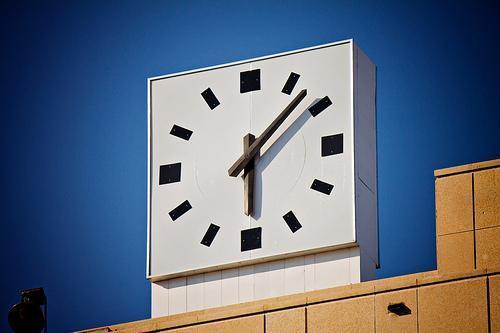How many hands are on the clock?
Give a very brief answer. 2. 